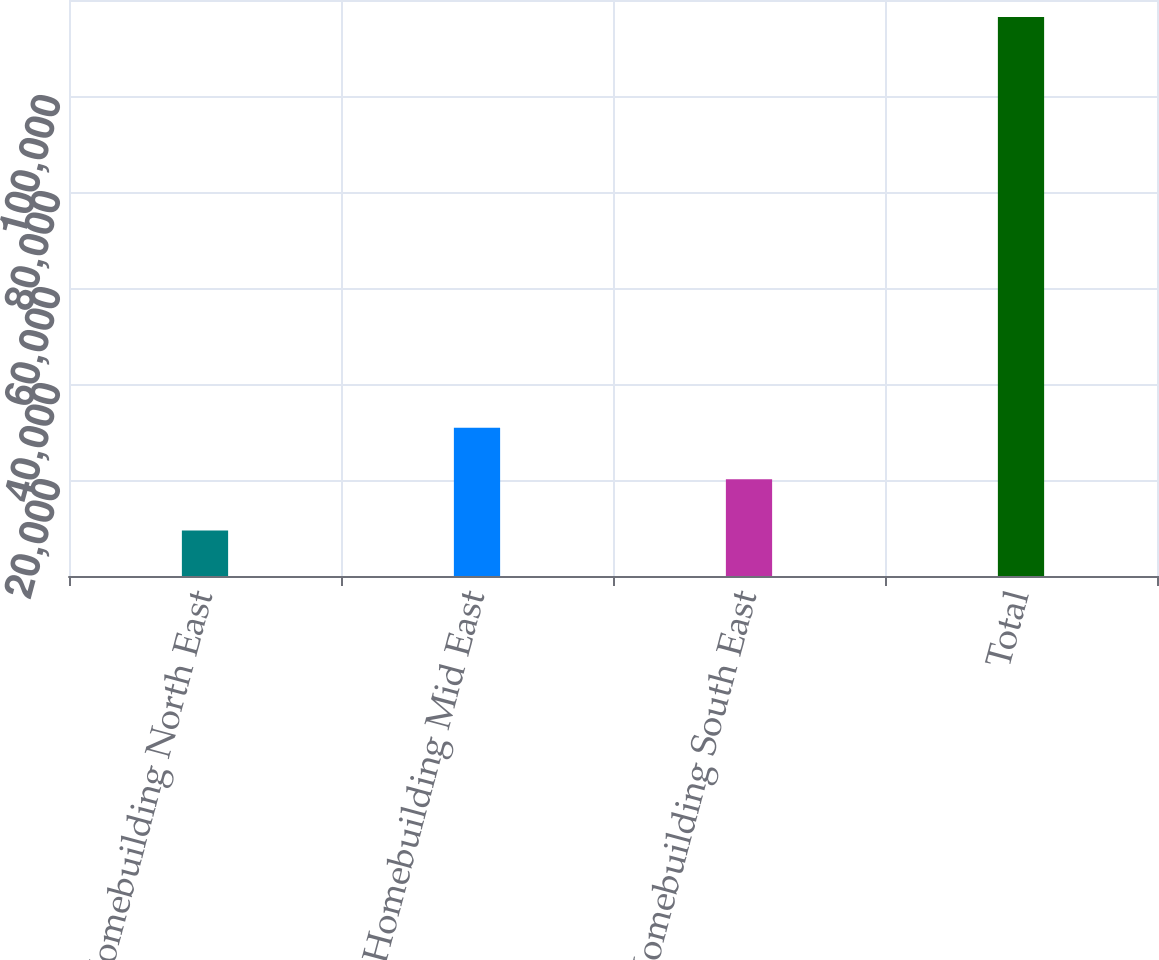<chart> <loc_0><loc_0><loc_500><loc_500><bar_chart><fcel>Homebuilding North East<fcel>Homebuilding Mid East<fcel>Homebuilding South East<fcel>Total<nl><fcel>9461<fcel>30860.2<fcel>20160.6<fcel>116457<nl></chart> 